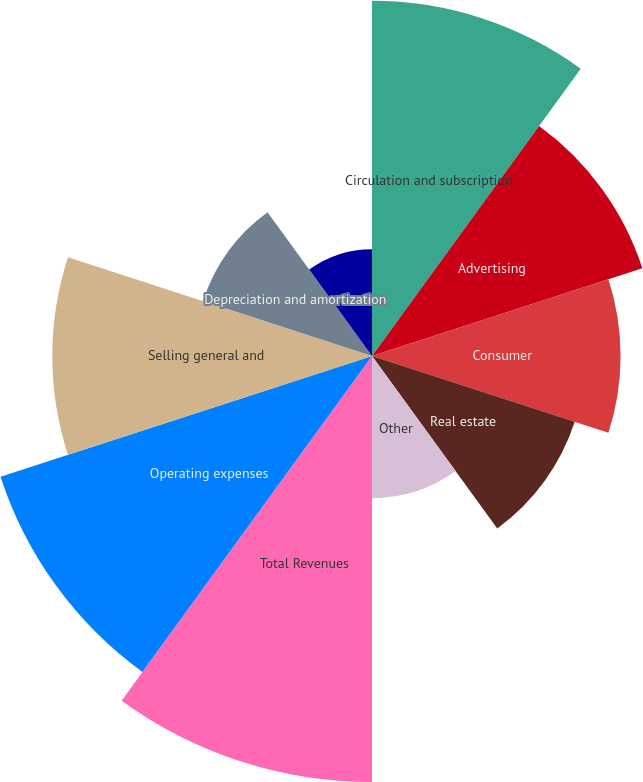Convert chart to OTSL. <chart><loc_0><loc_0><loc_500><loc_500><pie_chart><fcel>Circulation and subscription<fcel>Advertising<fcel>Consumer<fcel>Real estate<fcel>Other<fcel>Total Revenues<fcel>Operating expenses<fcel>Selling general and<fcel>Depreciation and amortization<fcel>Impairment and restructuring<nl><fcel>13.33%<fcel>10.67%<fcel>9.33%<fcel>8.0%<fcel>5.34%<fcel>15.99%<fcel>14.66%<fcel>12.0%<fcel>6.67%<fcel>4.01%<nl></chart> 